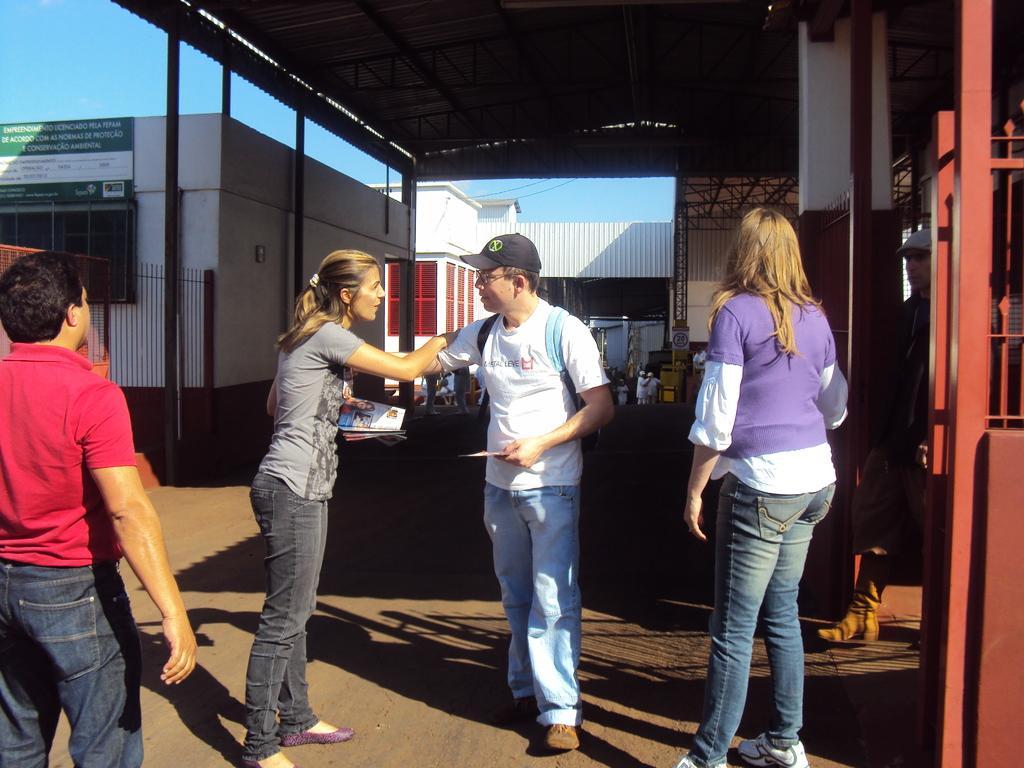In one or two sentences, can you explain what this image depicts? In this image we can see persons standing on the ground, buildings, fences, information boards, sheds, grills and sky. 